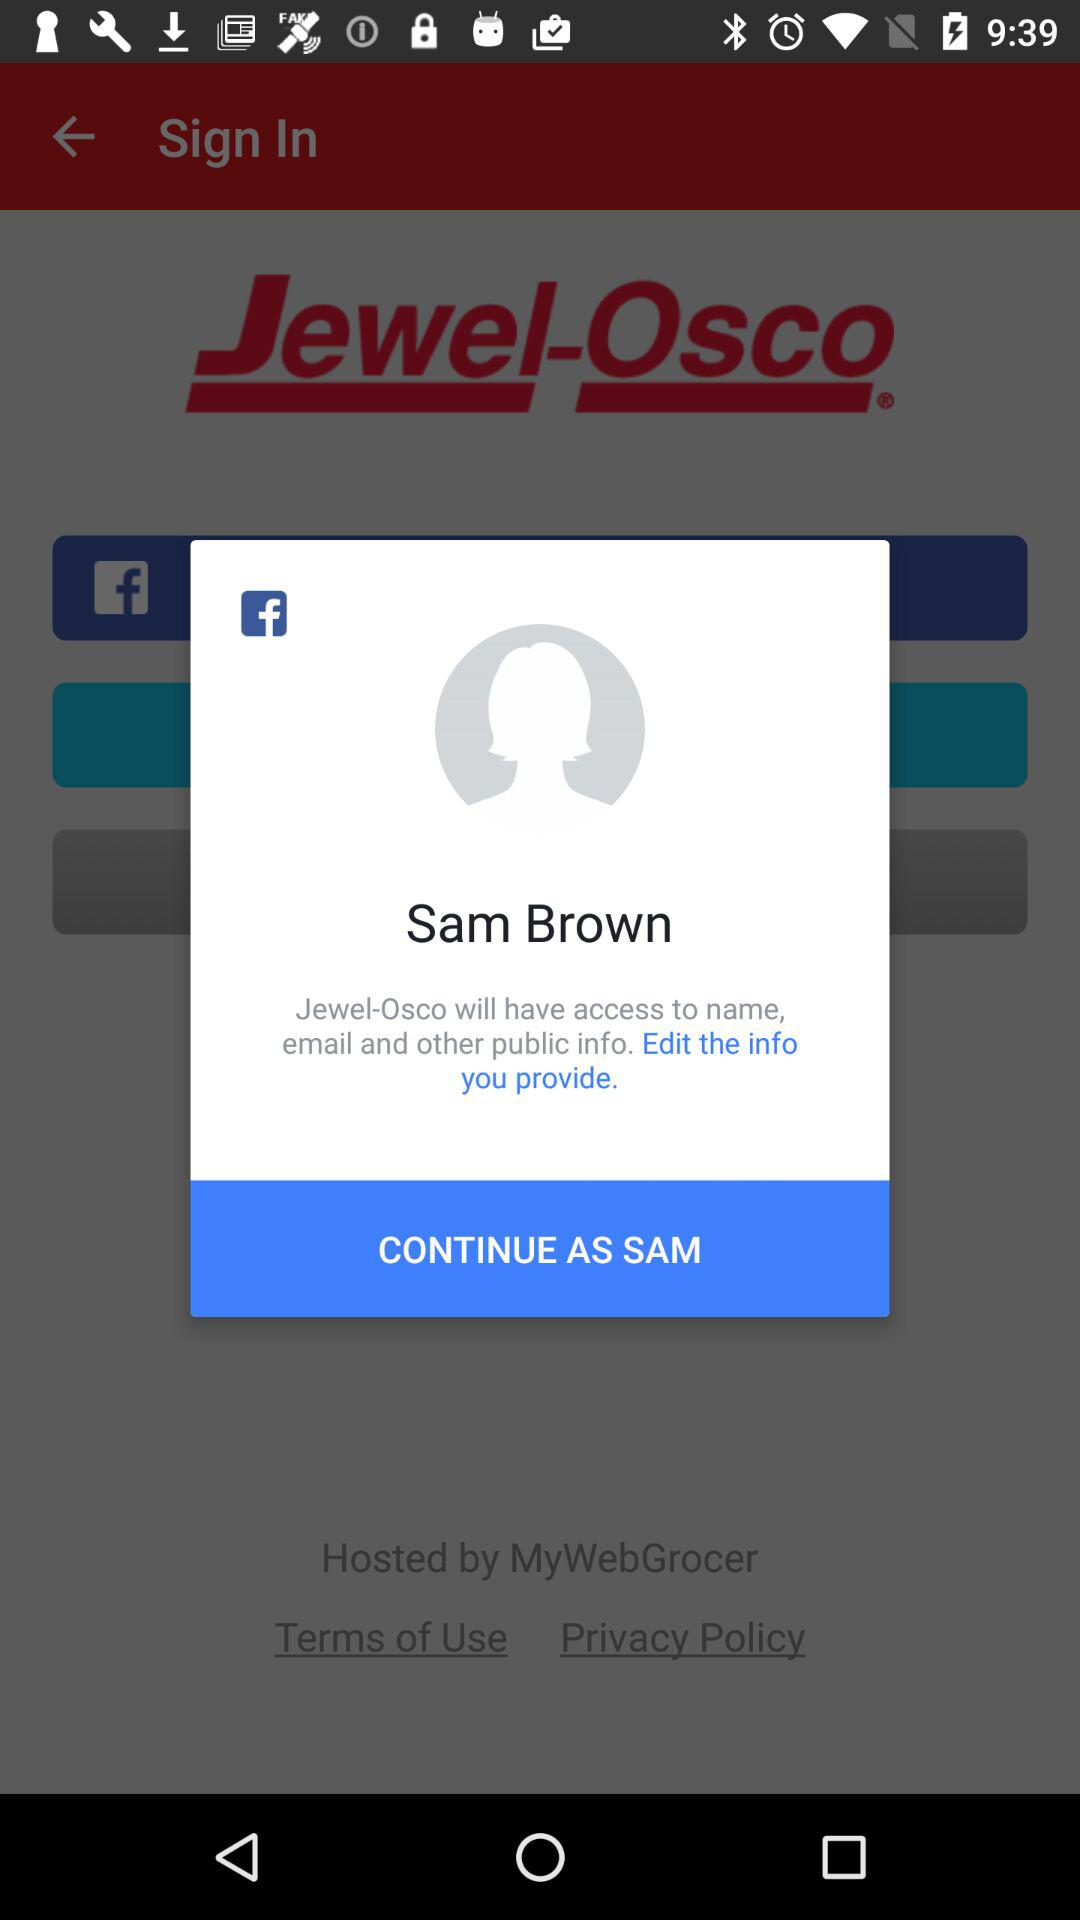What is the user name? The user name is Sam Brown. 